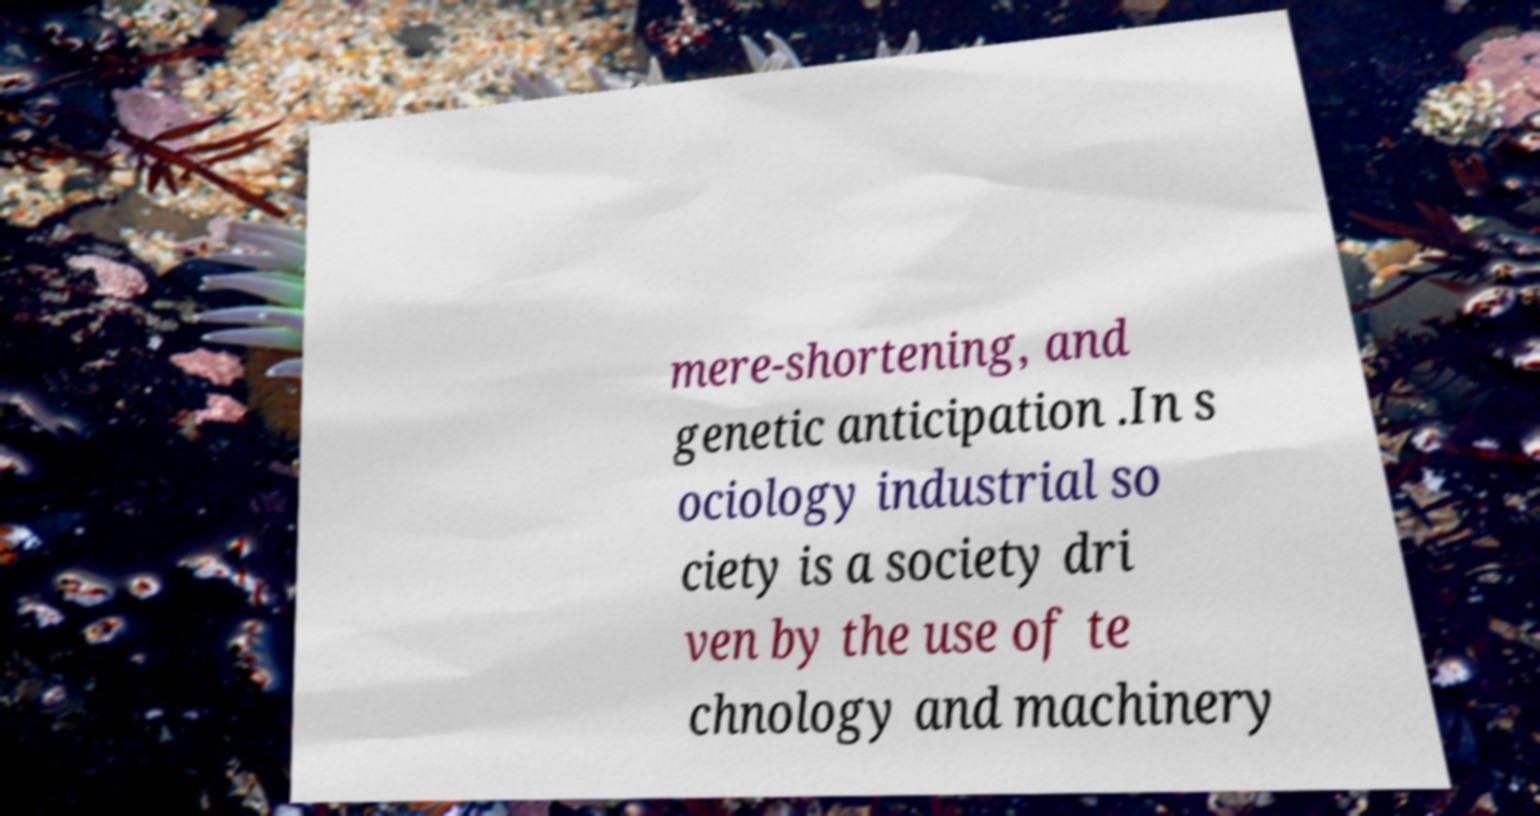I need the written content from this picture converted into text. Can you do that? mere-shortening, and genetic anticipation .In s ociology industrial so ciety is a society dri ven by the use of te chnology and machinery 